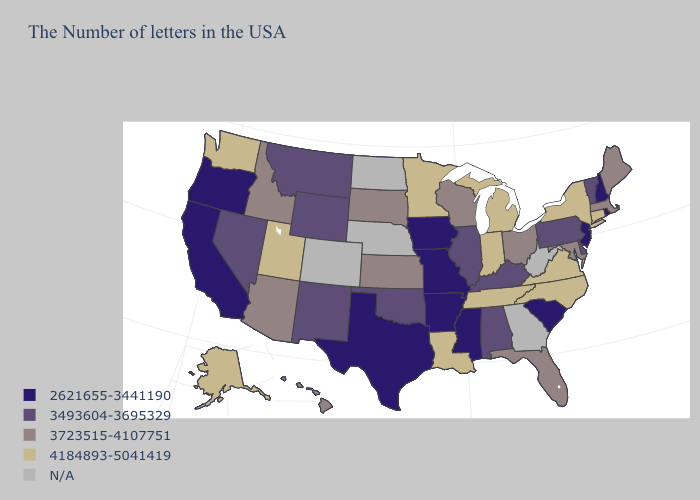Name the states that have a value in the range 2621655-3441190?
Write a very short answer. Rhode Island, New Hampshire, New Jersey, South Carolina, Mississippi, Missouri, Arkansas, Iowa, Texas, California, Oregon. Which states have the highest value in the USA?
Give a very brief answer. Connecticut, New York, Virginia, North Carolina, Michigan, Indiana, Tennessee, Louisiana, Minnesota, Utah, Washington, Alaska. Which states have the lowest value in the South?
Quick response, please. South Carolina, Mississippi, Arkansas, Texas. Name the states that have a value in the range N/A?
Write a very short answer. West Virginia, Georgia, Nebraska, North Dakota, Colorado. Which states have the lowest value in the South?
Answer briefly. South Carolina, Mississippi, Arkansas, Texas. What is the value of Florida?
Quick response, please. 3723515-4107751. Does New Jersey have the lowest value in the USA?
Answer briefly. Yes. What is the value of Utah?
Quick response, please. 4184893-5041419. Name the states that have a value in the range 3493604-3695329?
Give a very brief answer. Vermont, Delaware, Pennsylvania, Kentucky, Alabama, Illinois, Oklahoma, Wyoming, New Mexico, Montana, Nevada. What is the value of West Virginia?
Be succinct. N/A. What is the lowest value in the USA?
Keep it brief. 2621655-3441190. Name the states that have a value in the range 3493604-3695329?
Be succinct. Vermont, Delaware, Pennsylvania, Kentucky, Alabama, Illinois, Oklahoma, Wyoming, New Mexico, Montana, Nevada. What is the value of Arizona?
Short answer required. 3723515-4107751. Does the map have missing data?
Give a very brief answer. Yes. What is the value of Montana?
Give a very brief answer. 3493604-3695329. 